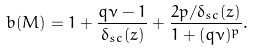<formula> <loc_0><loc_0><loc_500><loc_500>b ( M ) = 1 + \frac { q \nu - 1 } { \delta _ { s c } ( z ) } + \frac { 2 p / \delta _ { s c } ( z ) } { 1 + ( q \nu ) ^ { p } } .</formula> 